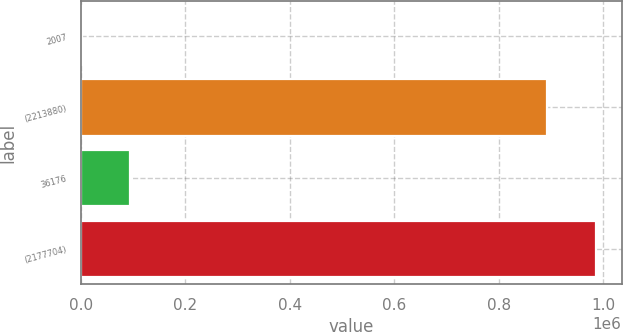Convert chart. <chart><loc_0><loc_0><loc_500><loc_500><bar_chart><fcel>2007<fcel>(2213880)<fcel>36176<fcel>(2177704)<nl><fcel>2006<fcel>893382<fcel>94685.1<fcel>986061<nl></chart> 